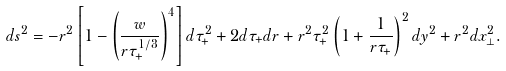<formula> <loc_0><loc_0><loc_500><loc_500>d s ^ { 2 } = - r ^ { 2 } \left [ 1 - \left ( \frac { w } { r \tau _ { + } ^ { 1 / 3 } } \right ) ^ { 4 } \right ] d \tau _ { + } ^ { 2 } + 2 d \tau _ { + } d r + r ^ { 2 } \tau _ { + } ^ { 2 } \left ( 1 + \frac { 1 } { r \tau _ { + } } \right ) ^ { 2 } d y ^ { 2 } + r ^ { 2 } d x _ { \perp } ^ { 2 } .</formula> 